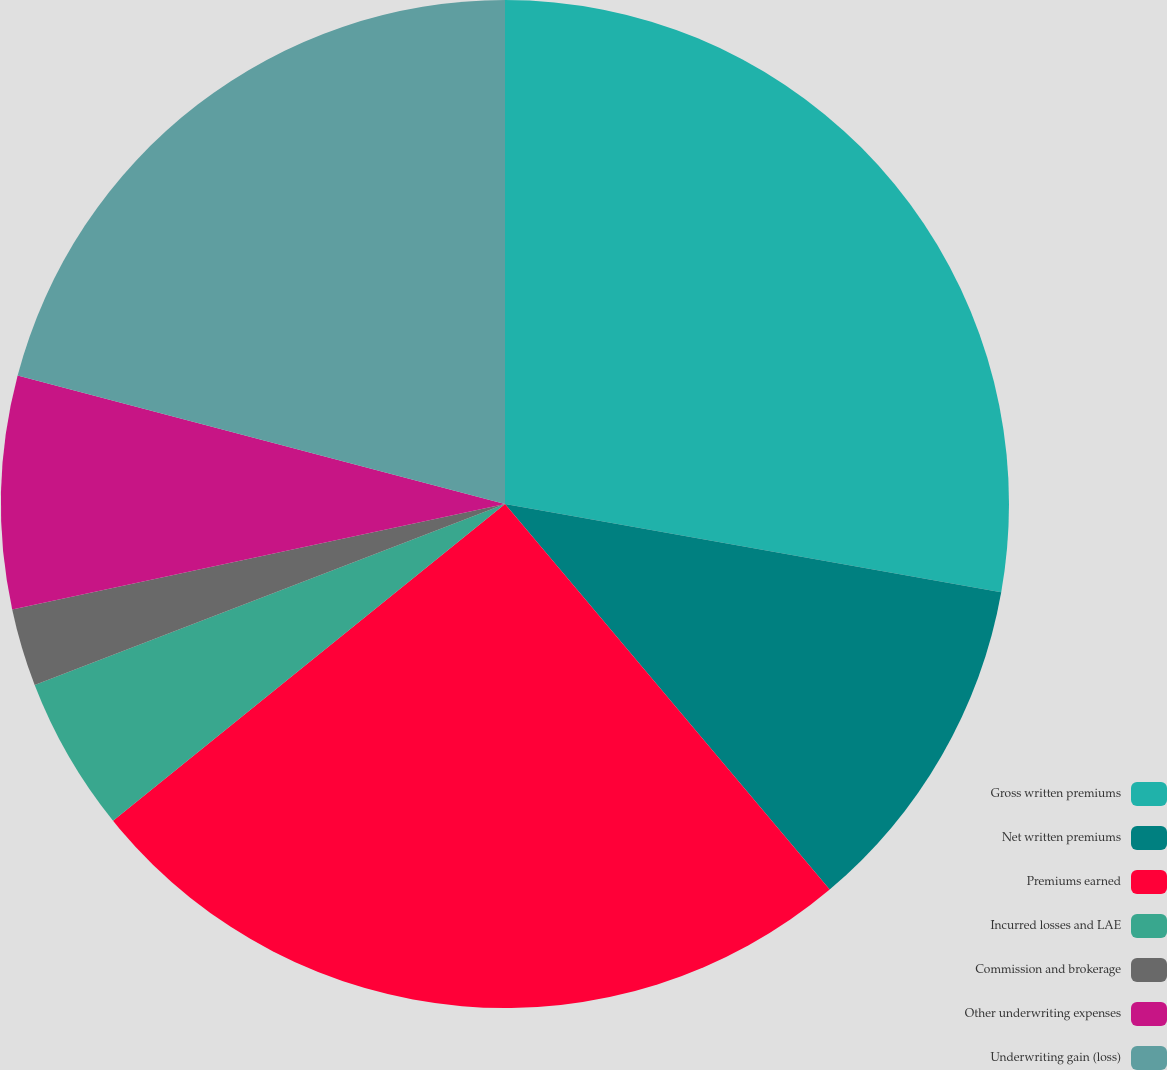<chart> <loc_0><loc_0><loc_500><loc_500><pie_chart><fcel>Gross written premiums<fcel>Net written premiums<fcel>Premiums earned<fcel>Incurred losses and LAE<fcel>Commission and brokerage<fcel>Other underwriting expenses<fcel>Underwriting gain (loss)<nl><fcel>27.8%<fcel>11.06%<fcel>25.32%<fcel>4.97%<fcel>2.49%<fcel>7.46%<fcel>20.9%<nl></chart> 